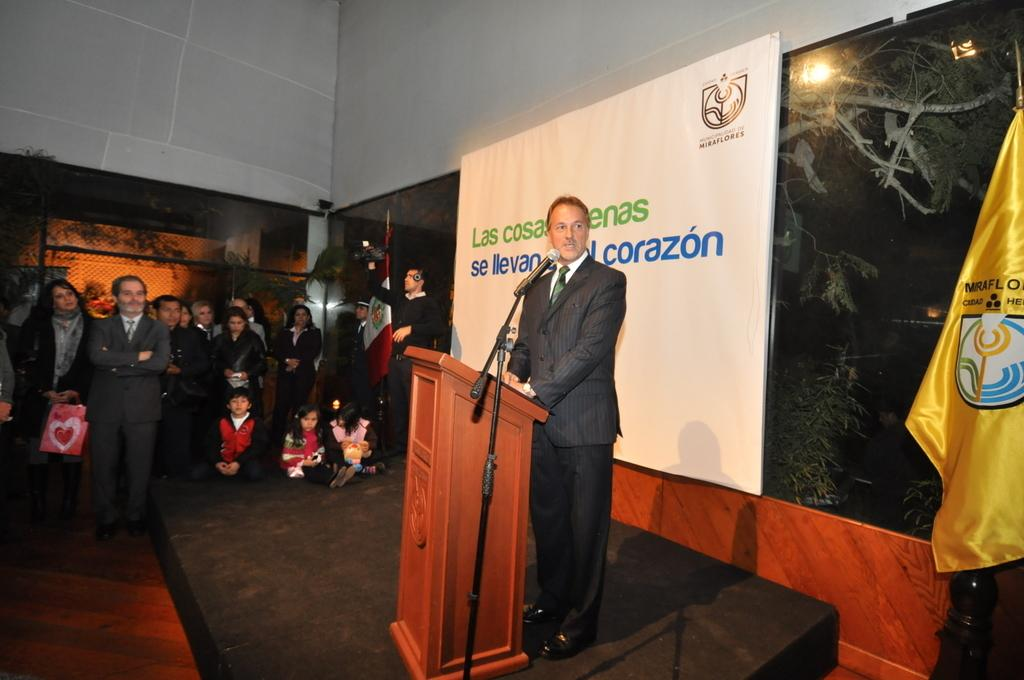What is the person in the image doing? The person is standing and talking in front of a microphone. Are there any other people in the image? Yes, there are people standing nearby. What can be seen on the wall in the image? There is a board on the wall. What is the flag associated with in the image? The flag is visible in the image. How does the earthquake affect the top of the cup in the image? There is no earthquake or cup present in the image, so this question cannot be answered. 